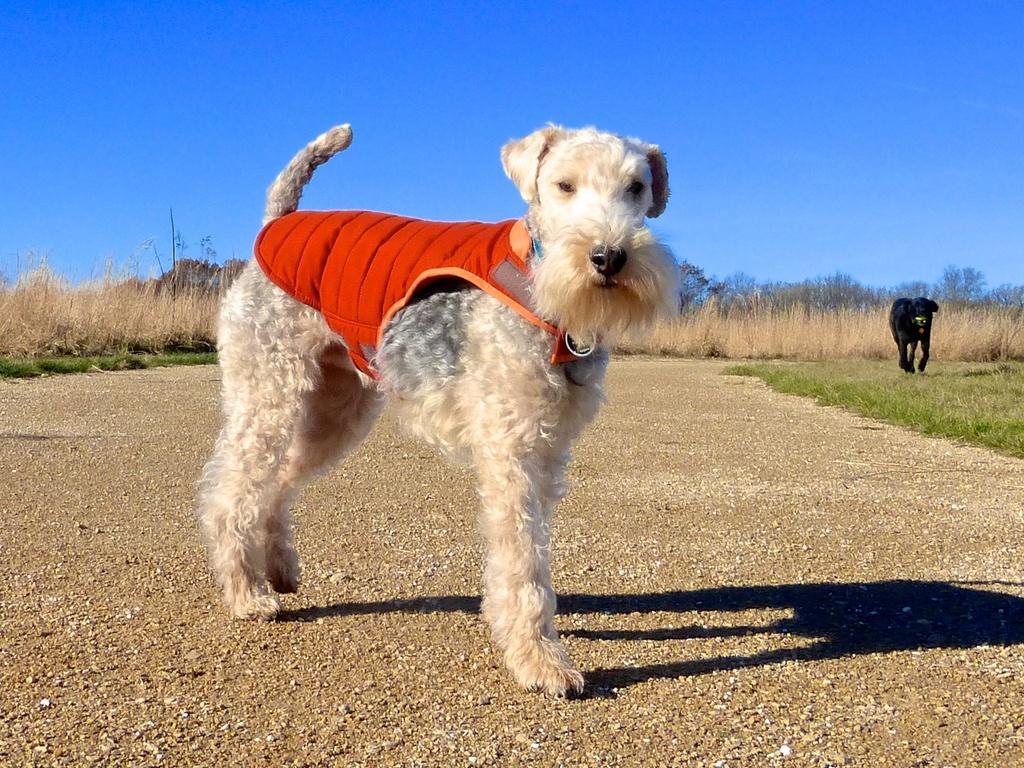Please provide a concise description of this image. In the foreground we can see a dog and soil. In the middle of the picture we can see plants, dog, grass, trees and other objects. At the top there is sky. 